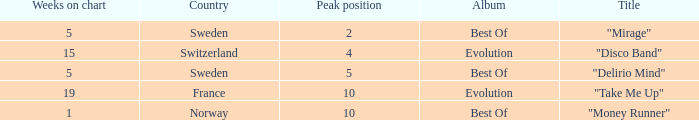What is the title of the single with the peak position of 10 and from France? "Take Me Up". 